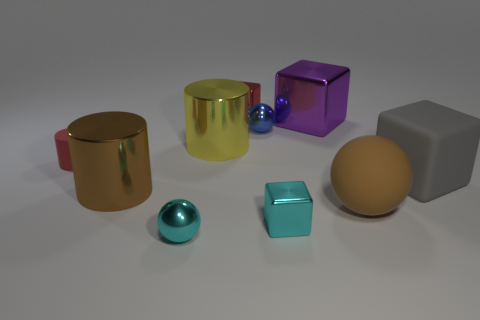How many objects are either tiny cubes in front of the large gray object or tiny things in front of the red shiny block?
Your response must be concise. 4. Are there fewer big cylinders that are in front of the big metallic cube than brown rubber things?
Offer a terse response. No. Are the red cube and the brown object to the right of the big brown metal thing made of the same material?
Ensure brevity in your answer.  No. What is the big brown cylinder made of?
Provide a short and direct response. Metal. What material is the small sphere that is on the left side of the small metal ball behind the ball that is in front of the large brown ball?
Ensure brevity in your answer.  Metal. There is a big sphere; is it the same color as the large object that is on the left side of the cyan ball?
Provide a short and direct response. Yes. The small metal ball to the left of the tiny red object that is behind the red rubber object is what color?
Keep it short and to the point. Cyan. How many cyan things are there?
Keep it short and to the point. 2. How many metal things are large gray things or small purple cylinders?
Your answer should be compact. 0. How many metal cylinders have the same color as the matte ball?
Keep it short and to the point. 1. 